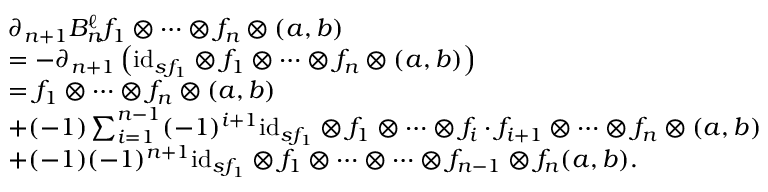<formula> <loc_0><loc_0><loc_500><loc_500>\begin{array} { r l } & { \partial _ { n + 1 } B _ { n } ^ { \ell } f _ { 1 } \otimes \dots \otimes f _ { n } \otimes ( a , b ) } \\ & { = - \partial _ { n + 1 } \left ( i d _ { s f _ { 1 } } \otimes f _ { 1 } \otimes \dots \otimes f _ { n } \otimes ( a , b ) \right ) } \\ & { = f _ { 1 } \otimes \dots \otimes f _ { n } \otimes ( a , b ) } \\ & { + ( - 1 ) \sum _ { i = 1 } ^ { n - 1 } ( - 1 ) ^ { i + 1 } i d _ { s f _ { 1 } } \otimes f _ { 1 } \otimes \dots \otimes f _ { i } \cdot f _ { i + 1 } \otimes \dots \otimes f _ { n } \otimes ( a , b ) } \\ & { + ( - 1 ) ( - 1 ) ^ { n + 1 } i d _ { s f _ { 1 } } \otimes f _ { 1 } \otimes \dots \otimes \dots \otimes f _ { n - 1 } \otimes f _ { n } ( a , b ) . } \end{array}</formula> 